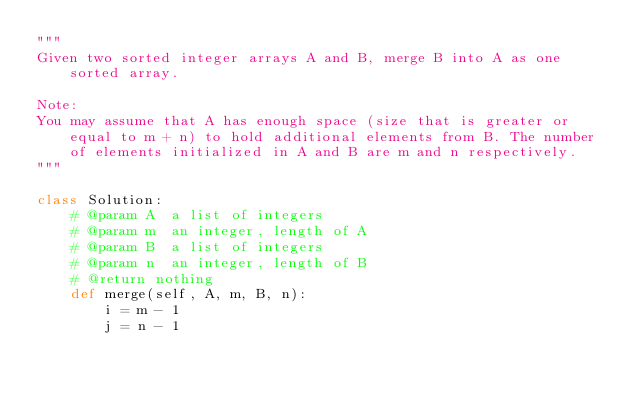Convert code to text. <code><loc_0><loc_0><loc_500><loc_500><_Python_>"""
Given two sorted integer arrays A and B, merge B into A as one sorted array.

Note:
You may assume that A has enough space (size that is greater or equal to m + n) to hold additional elements from B. The number of elements initialized in A and B are m and n respectively.
"""

class Solution:
    # @param A  a list of integers
    # @param m  an integer, length of A
    # @param B  a list of integers
    # @param n  an integer, length of B
    # @return nothing
    def merge(self, A, m, B, n):
        i = m - 1
        j = n - 1</code> 